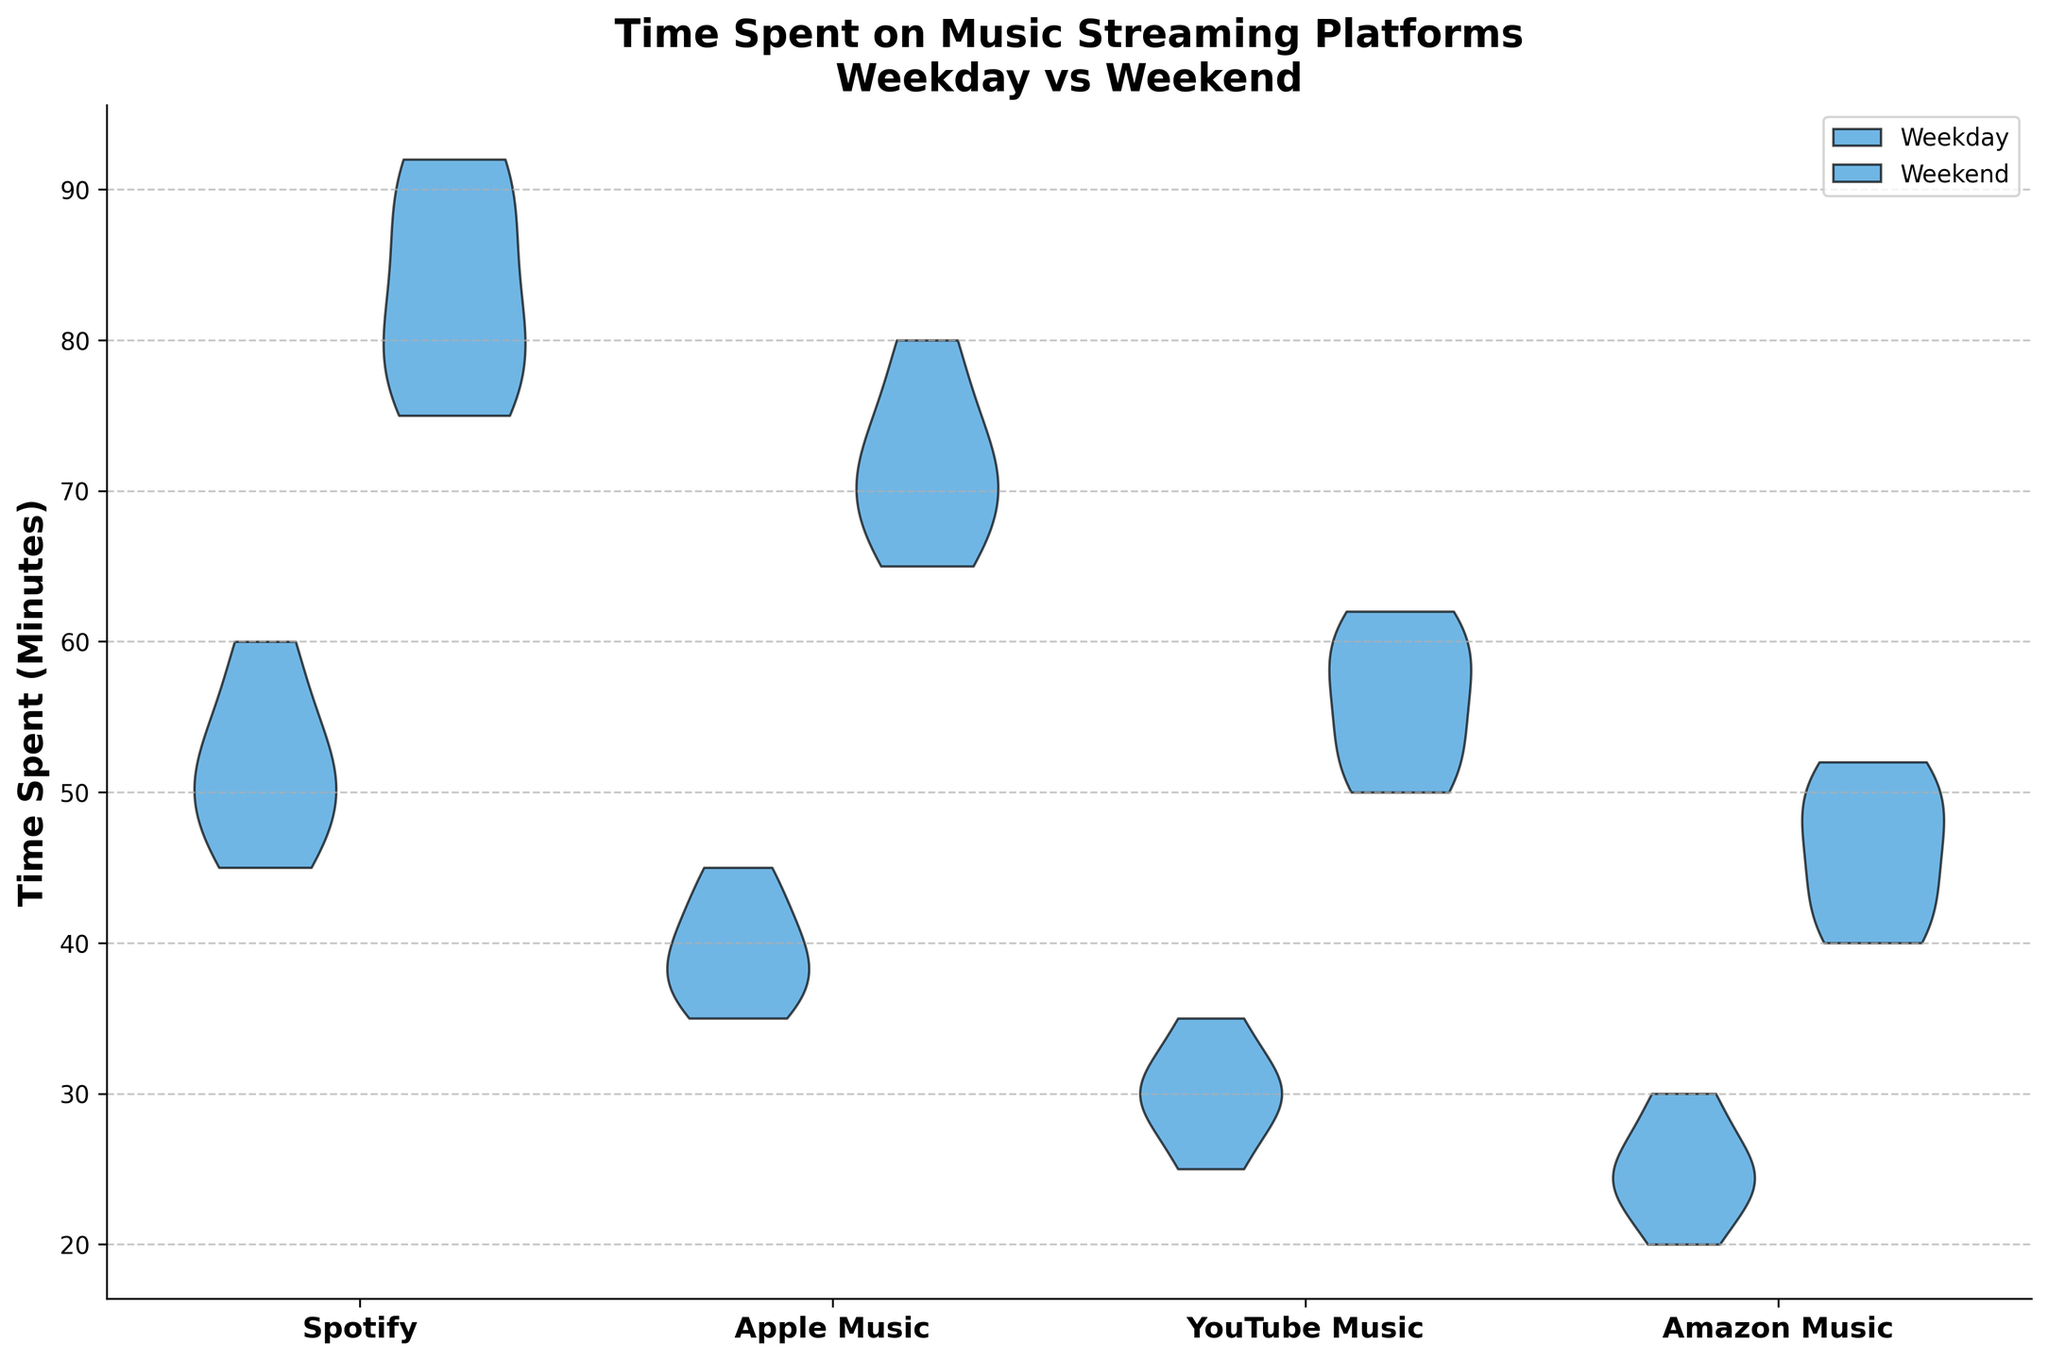What is the title of the chart? The title is written at the top of the chart and provides the main subject of the figure, which is about the time spent on different music streaming platforms during weekdays versus weekends.
Answer: Time Spent on Music Streaming Platforms: Weekday vs Weekend Which platform appears to have the highest average time spent on weekends? By observing the spread and central tendency of the violin plots for each platform on weekends, the platform with the higher average time spent on weekends can be identified.
Answer: Spotify How do the time spent distributions for weekdays and weekends differ on Spotify? On Spotify, compare the spread and fill of the violin plots for weekdays (positioned to the left) and weekends (positioned to the right). Weekends show a wider distribution with higher values.
Answer: Higher and more spread out on weekends Which day of the week shows a wider variance in time spent on Amazon Music? By comparing the widths of the violin plots for Amazon Music on weekdays and weekends, the day with the wider variance can be inferred based on the spread of the plot.
Answer: Weekend How does the time spent on Apple Music during weekends compare with weekdays? By comparing the central tendency and spread of the violin plots of Apple Music for both weekdays and weekends, we can analyze the differences. Weekends show higher central values and a broader spread.
Answer: Higher on weekends Is the time spent on YouTube Music during weekdays generally lower than during weekends? By comparing the position of the central mass and overall spread of the YouTube Music violin plots, it can be determined that weekends have higher and more widespread values.
Answer: Yes What is the y-axis label in the chart? The y-axis label, written vertically along the y-axis, indicates what the numbers along the y-axis represent. In this case, it measures the time spent on music platforms in minutes.
Answer: Time Spent (Minutes) Compare the variability of time spent on weekdays between all platforms. Which platform shows the least variability? By comparing the spread of the weekday violin plots for all platforms, Amazon Music shows the least variance (narrowest spread).
Answer: Amazon Music Which platform shows a more noticeable increase in time spent from weekdays to weekends? By comparing the shift in the central tendency and spread of the violin plots from weekdays to weekends across platforms, Spotify exhibits a more noticeable increase.
Answer: Spotify Which platforms have overlapping ranges of time spent during weekdays and weekends? By looking at the tails and spread of the violin plots for each platform, Amazon Music, and YouTube Music showcase significant overlap in time ranges between weekdays and weekends.
Answer: Amazon Music, YouTube Music 